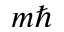<formula> <loc_0><loc_0><loc_500><loc_500>m \hbar</formula> 